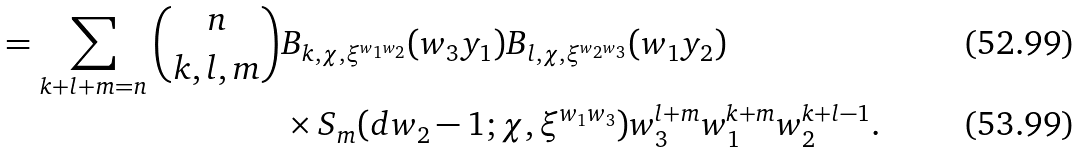<formula> <loc_0><loc_0><loc_500><loc_500>= \sum _ { k + l + m = n } \binom { n } { k , l , m } & B _ { k , \chi , \xi ^ { w _ { 1 } w _ { 2 } } } ( w _ { 3 } y _ { 1 } ) B _ { l , \chi , \xi ^ { w _ { 2 } w _ { 3 } } } ( w _ { 1 } y _ { 2 } ) \\ & \times S _ { m } ( d w _ { 2 } - 1 ; \chi , \xi ^ { w _ { 1 } w _ { 3 } } ) w _ { 3 } ^ { l + m } w _ { 1 } ^ { k + m } w _ { 2 } ^ { k + l - 1 } .</formula> 